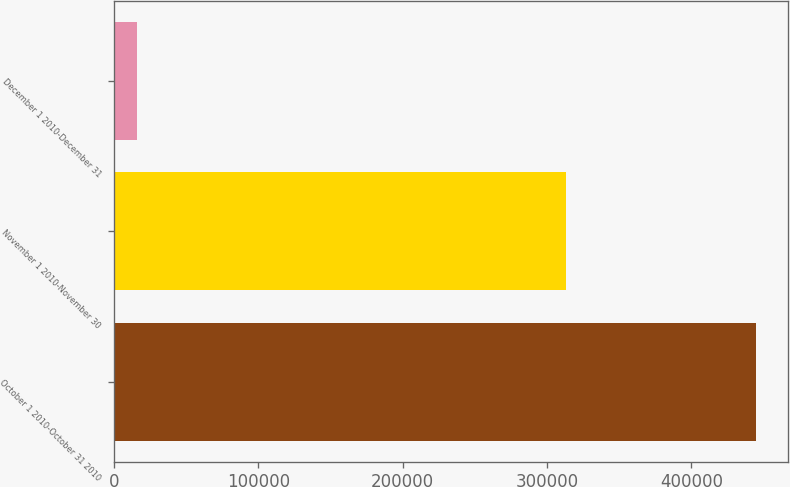Convert chart. <chart><loc_0><loc_0><loc_500><loc_500><bar_chart><fcel>October 1 2010-October 31 2010<fcel>November 1 2010-November 30<fcel>December 1 2010-December 31<nl><fcel>444480<fcel>312770<fcel>16139<nl></chart> 